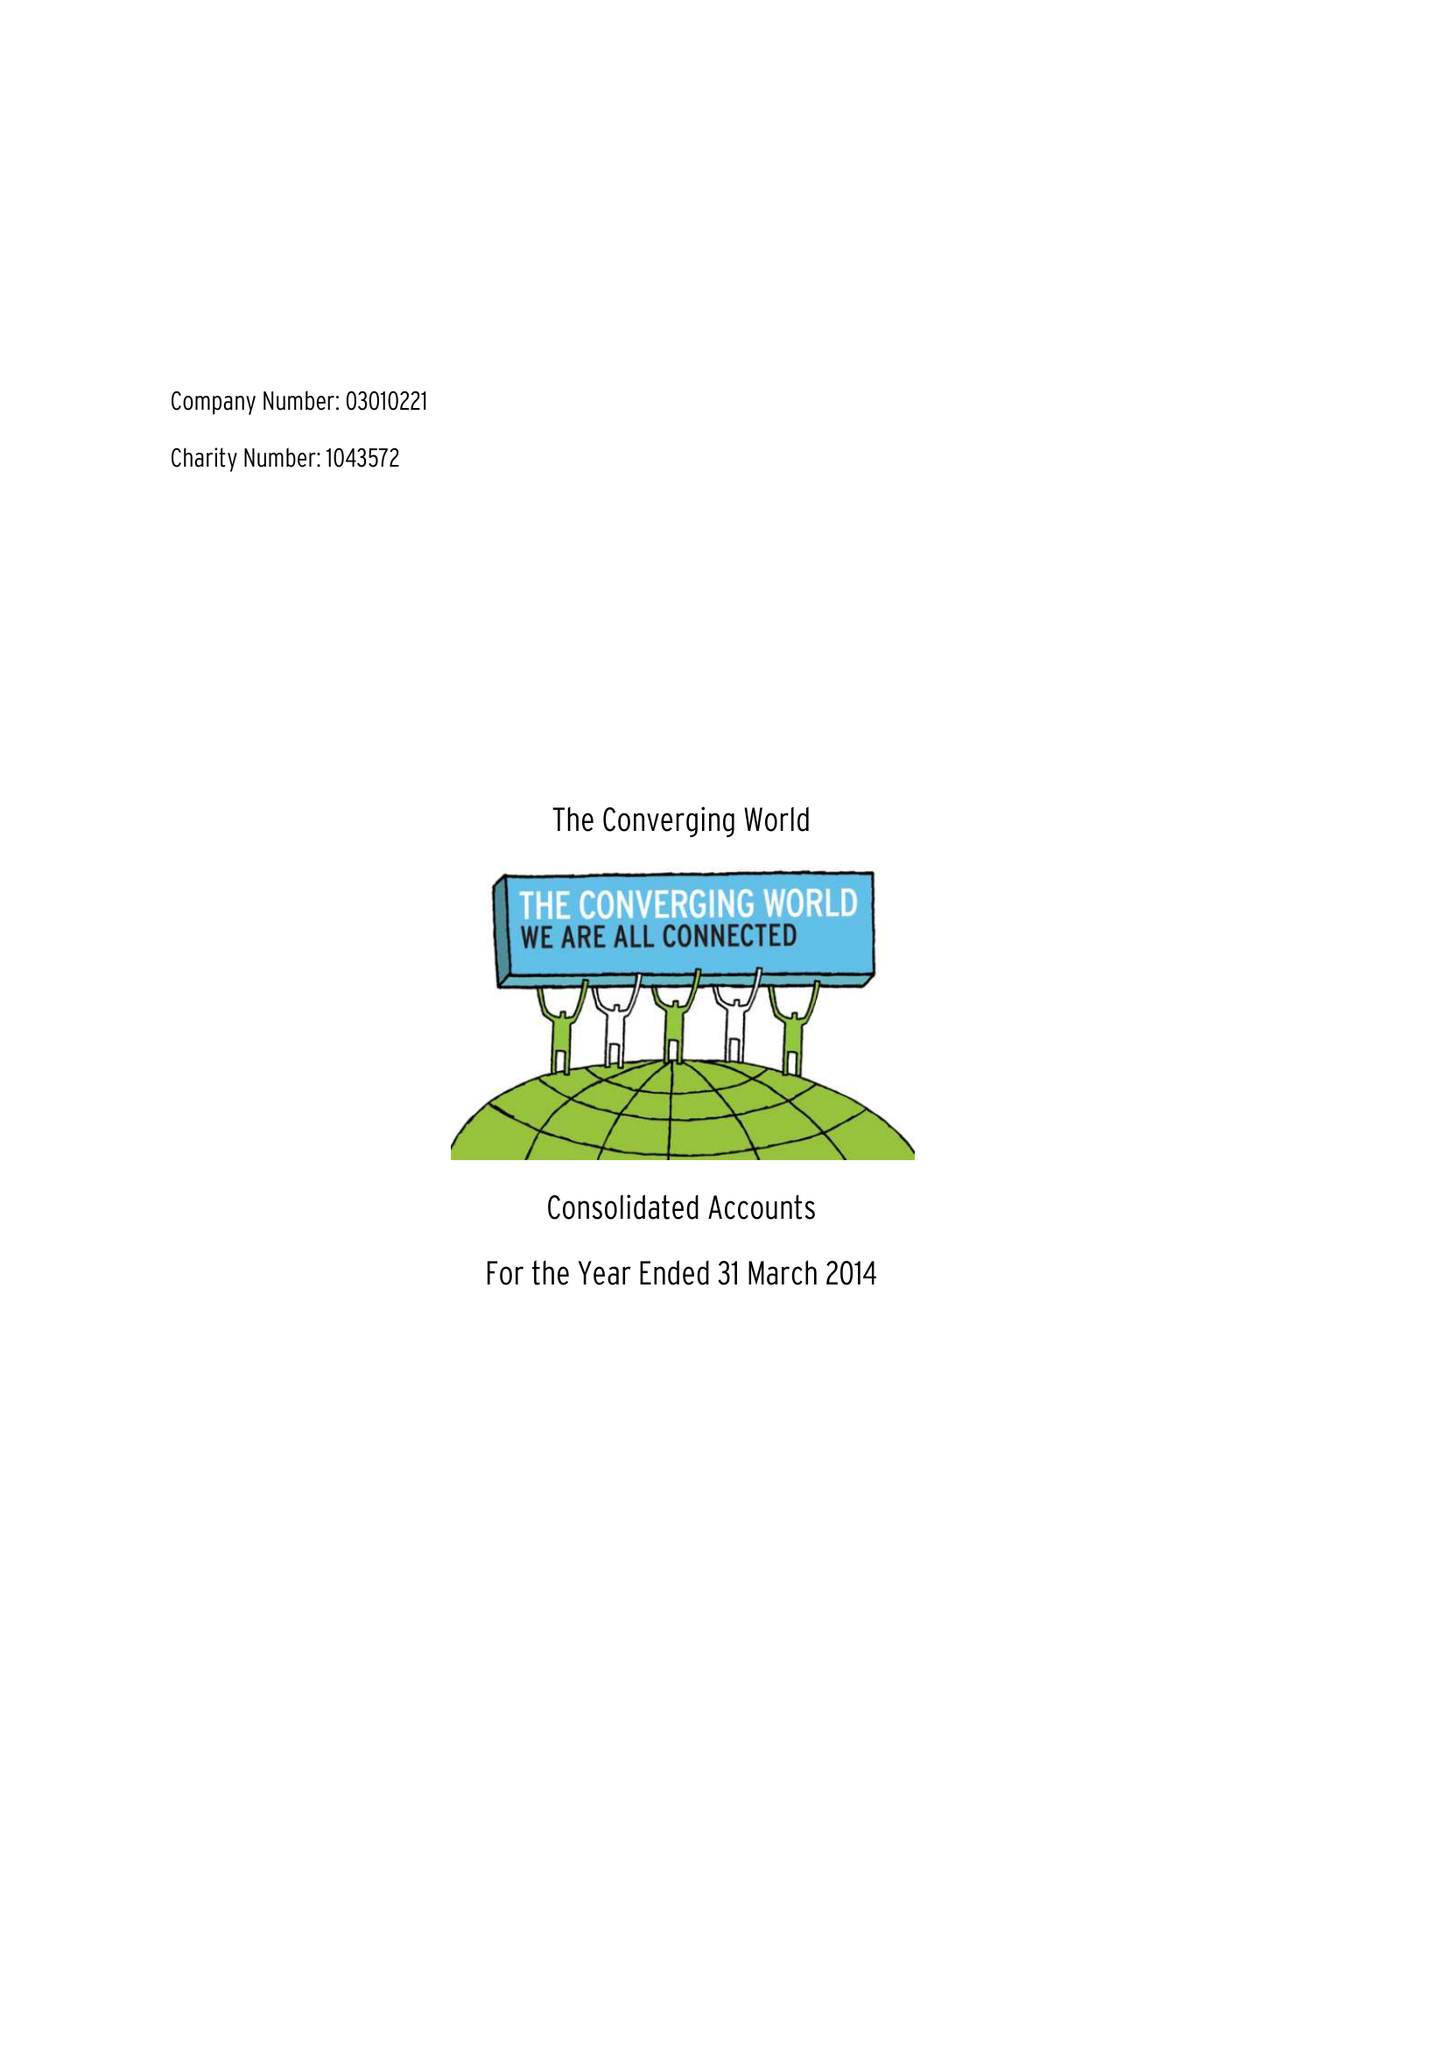What is the value for the address__post_town?
Answer the question using a single word or phrase. BRISTOL 